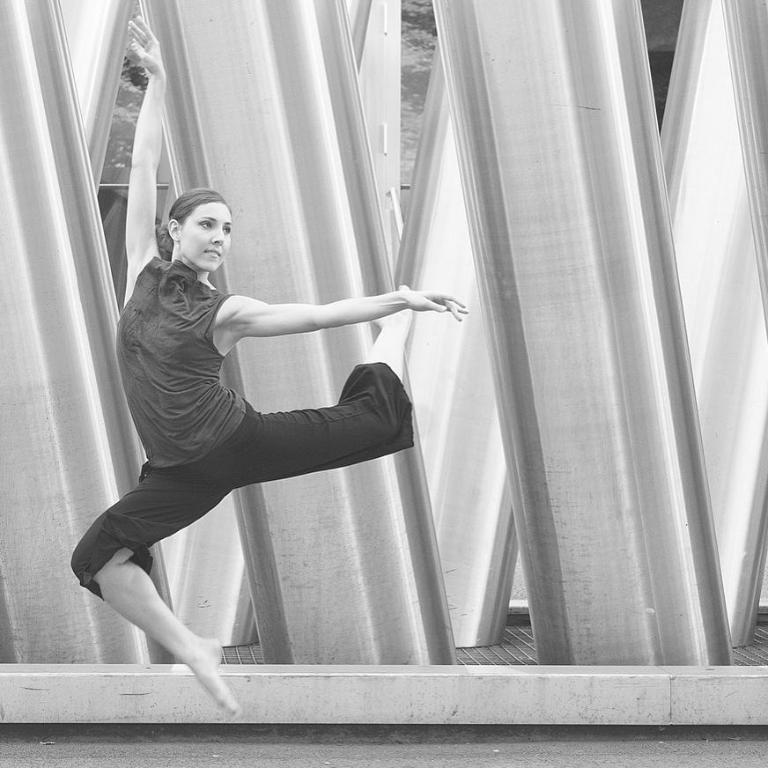Who is the main subject in the image? There is a woman in the image. What is the woman doing in the image? The woman is in a pose. What can be seen behind the woman in the image? There are pillars visible behind the woman. What type of afterthought is the woman having in the image? There is no indication of any afterthought in the image; the woman is simply posing. 